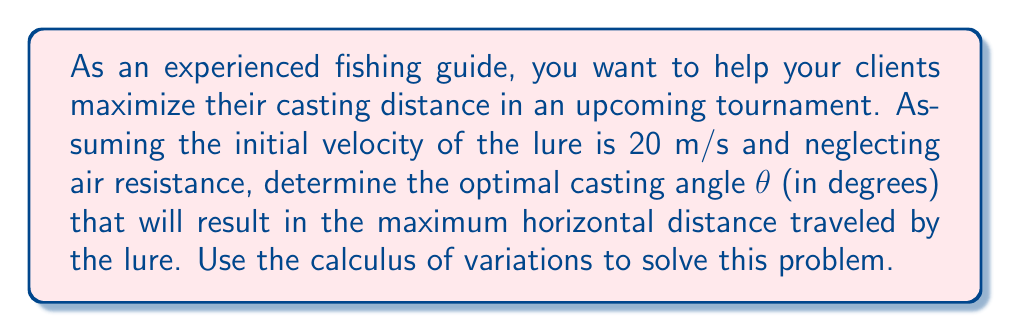Could you help me with this problem? Let's approach this step-by-step using the calculus of variations:

1) The horizontal distance traveled by a projectile (in this case, the fishing lure) is given by:

   $$x = \frac{v_0^2}{g} \sin(2\theta)$$

   where $v_0$ is the initial velocity, $g$ is the acceleration due to gravity (9.8 m/s²), and $\theta$ is the angle of launch.

2) To find the maximum distance, we need to find the value of $\theta$ that maximizes this function. We can do this by taking the derivative with respect to $\theta$ and setting it equal to zero:

   $$\frac{dx}{d\theta} = \frac{v_0^2}{g} \cdot 2\cos(2\theta) = 0$$

3) Solving this equation:

   $$2\cos(2\theta) = 0$$
   $$\cos(2\theta) = 0$$

4) The cosine function equals zero when its argument is $\frac{\pi}{2}$ or $\frac{3\pi}{2}$ radians. Since we're dealing with a launch angle, we're interested in the solution in the first quadrant:

   $$2\theta = \frac{\pi}{2}$$
   $$\theta = \frac{\pi}{4} = 45°$$

5) To confirm this is a maximum (not a minimum), we can check the second derivative:

   $$\frac{d^2x}{d\theta^2} = \frac{v_0^2}{g} \cdot (-4\sin(2\theta))$$

   At $\theta = 45°$, this is negative, confirming a maximum.

6) Therefore, the optimal casting angle for maximum distance is 45°, regardless of the initial velocity (assuming no air resistance).
Answer: 45° 